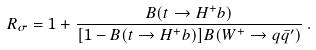Convert formula to latex. <formula><loc_0><loc_0><loc_500><loc_500>R _ { \sigma } = 1 + \frac { B ( t \to H ^ { + } b ) } { [ 1 - B ( t \to H ^ { + } b ) ] B ( W ^ { + } \to q \bar { q } ^ { \prime } ) } \, .</formula> 